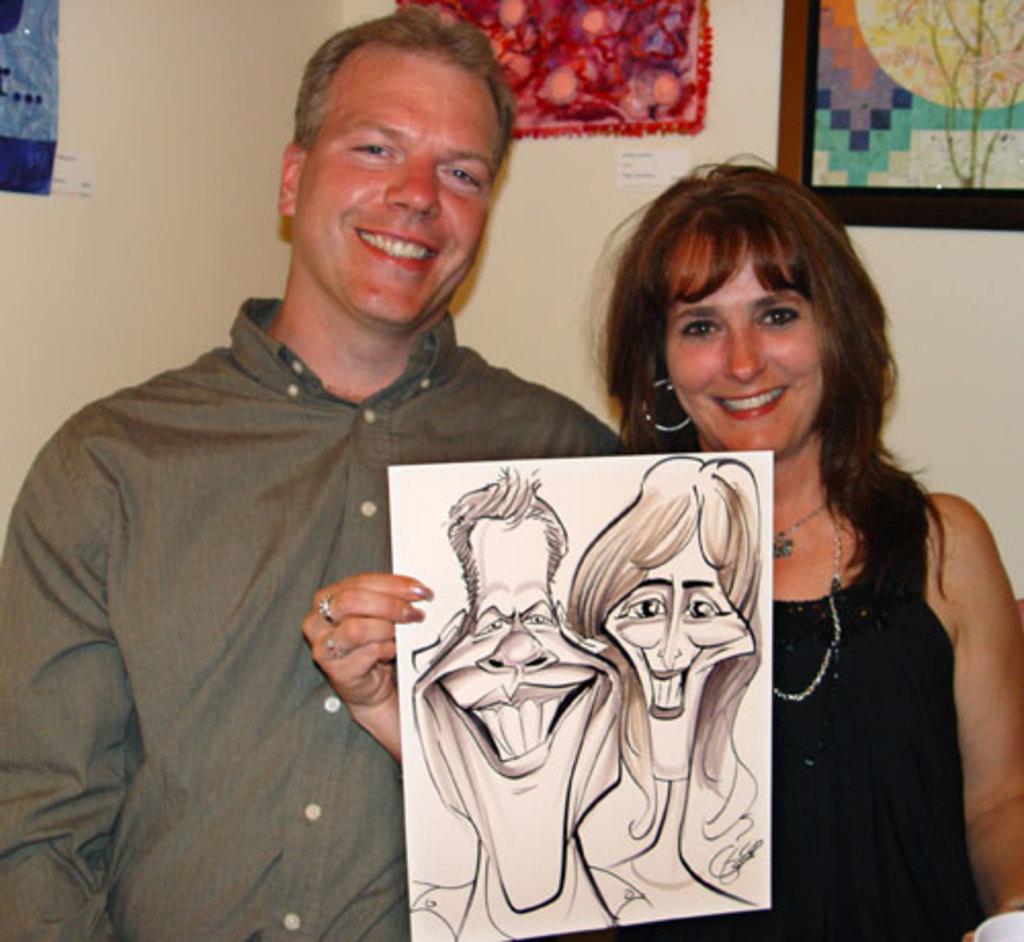Describe this image in one or two sentences. In this image there is a person wearing a shirt. Beside him there is a woman wearing a black top. She is holding a paper. There is a painting on the paper. A picture frame and few posters are attached to the wall. 